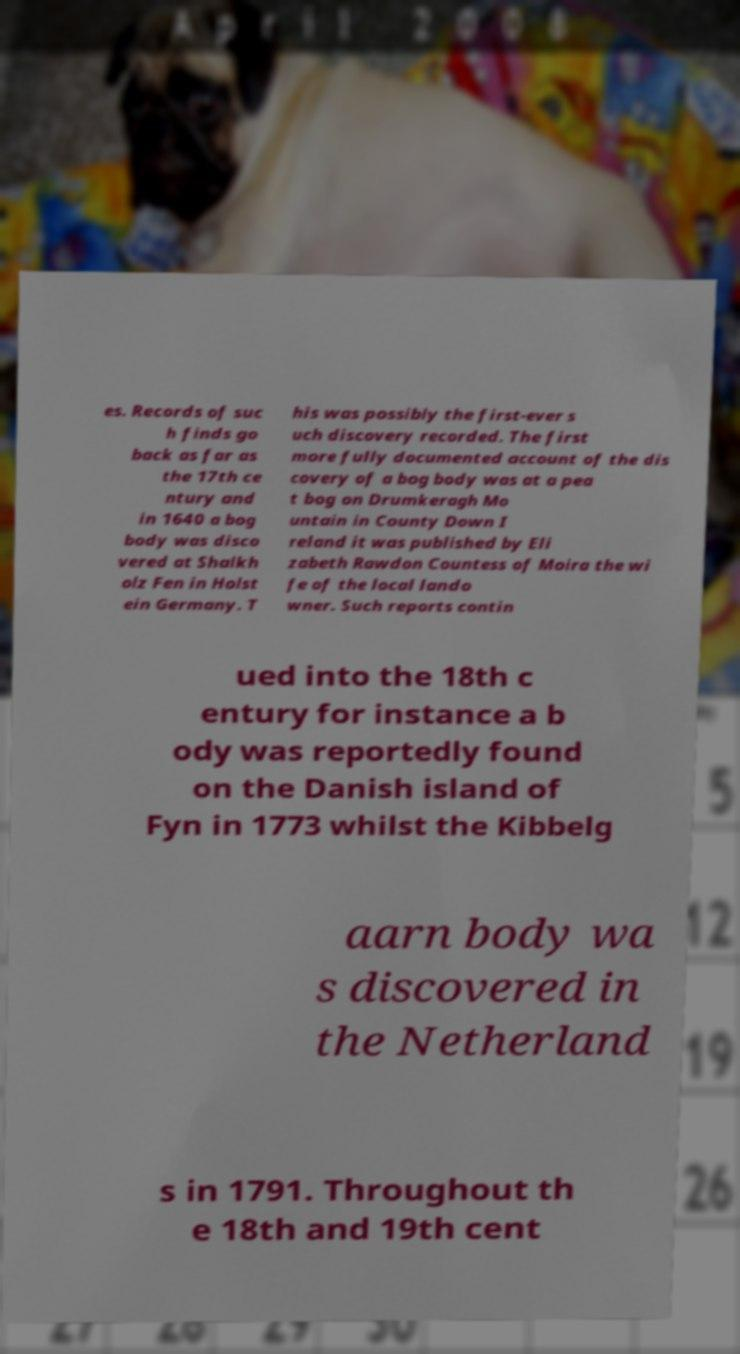Could you extract and type out the text from this image? es. Records of suc h finds go back as far as the 17th ce ntury and in 1640 a bog body was disco vered at Shalkh olz Fen in Holst ein Germany. T his was possibly the first-ever s uch discovery recorded. The first more fully documented account of the dis covery of a bog body was at a pea t bog on Drumkeragh Mo untain in County Down I reland it was published by Eli zabeth Rawdon Countess of Moira the wi fe of the local lando wner. Such reports contin ued into the 18th c entury for instance a b ody was reportedly found on the Danish island of Fyn in 1773 whilst the Kibbelg aarn body wa s discovered in the Netherland s in 1791. Throughout th e 18th and 19th cent 